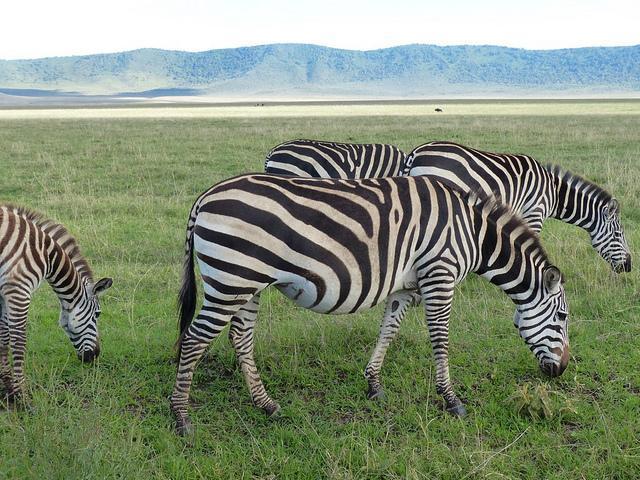What are the zebras doing?
Make your selection and explain in format: 'Answer: answer
Rationale: rationale.'
Options: Grazing, mating, sleeping, fighting. Answer: grazing.
Rationale: The zebras are bent with their muzzles to the grass which is consistent with how they eat and with answer a. 